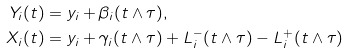<formula> <loc_0><loc_0><loc_500><loc_500>Y _ { i } ( t ) & = y _ { i } + \beta _ { i } ( t \wedge \tau ) , \\ X _ { i } ( t ) & = y _ { i } + \gamma _ { i } ( t \wedge \tau ) + L _ { i } ^ { - } ( t \wedge \tau ) - L _ { i } ^ { + } ( t \wedge \tau )</formula> 